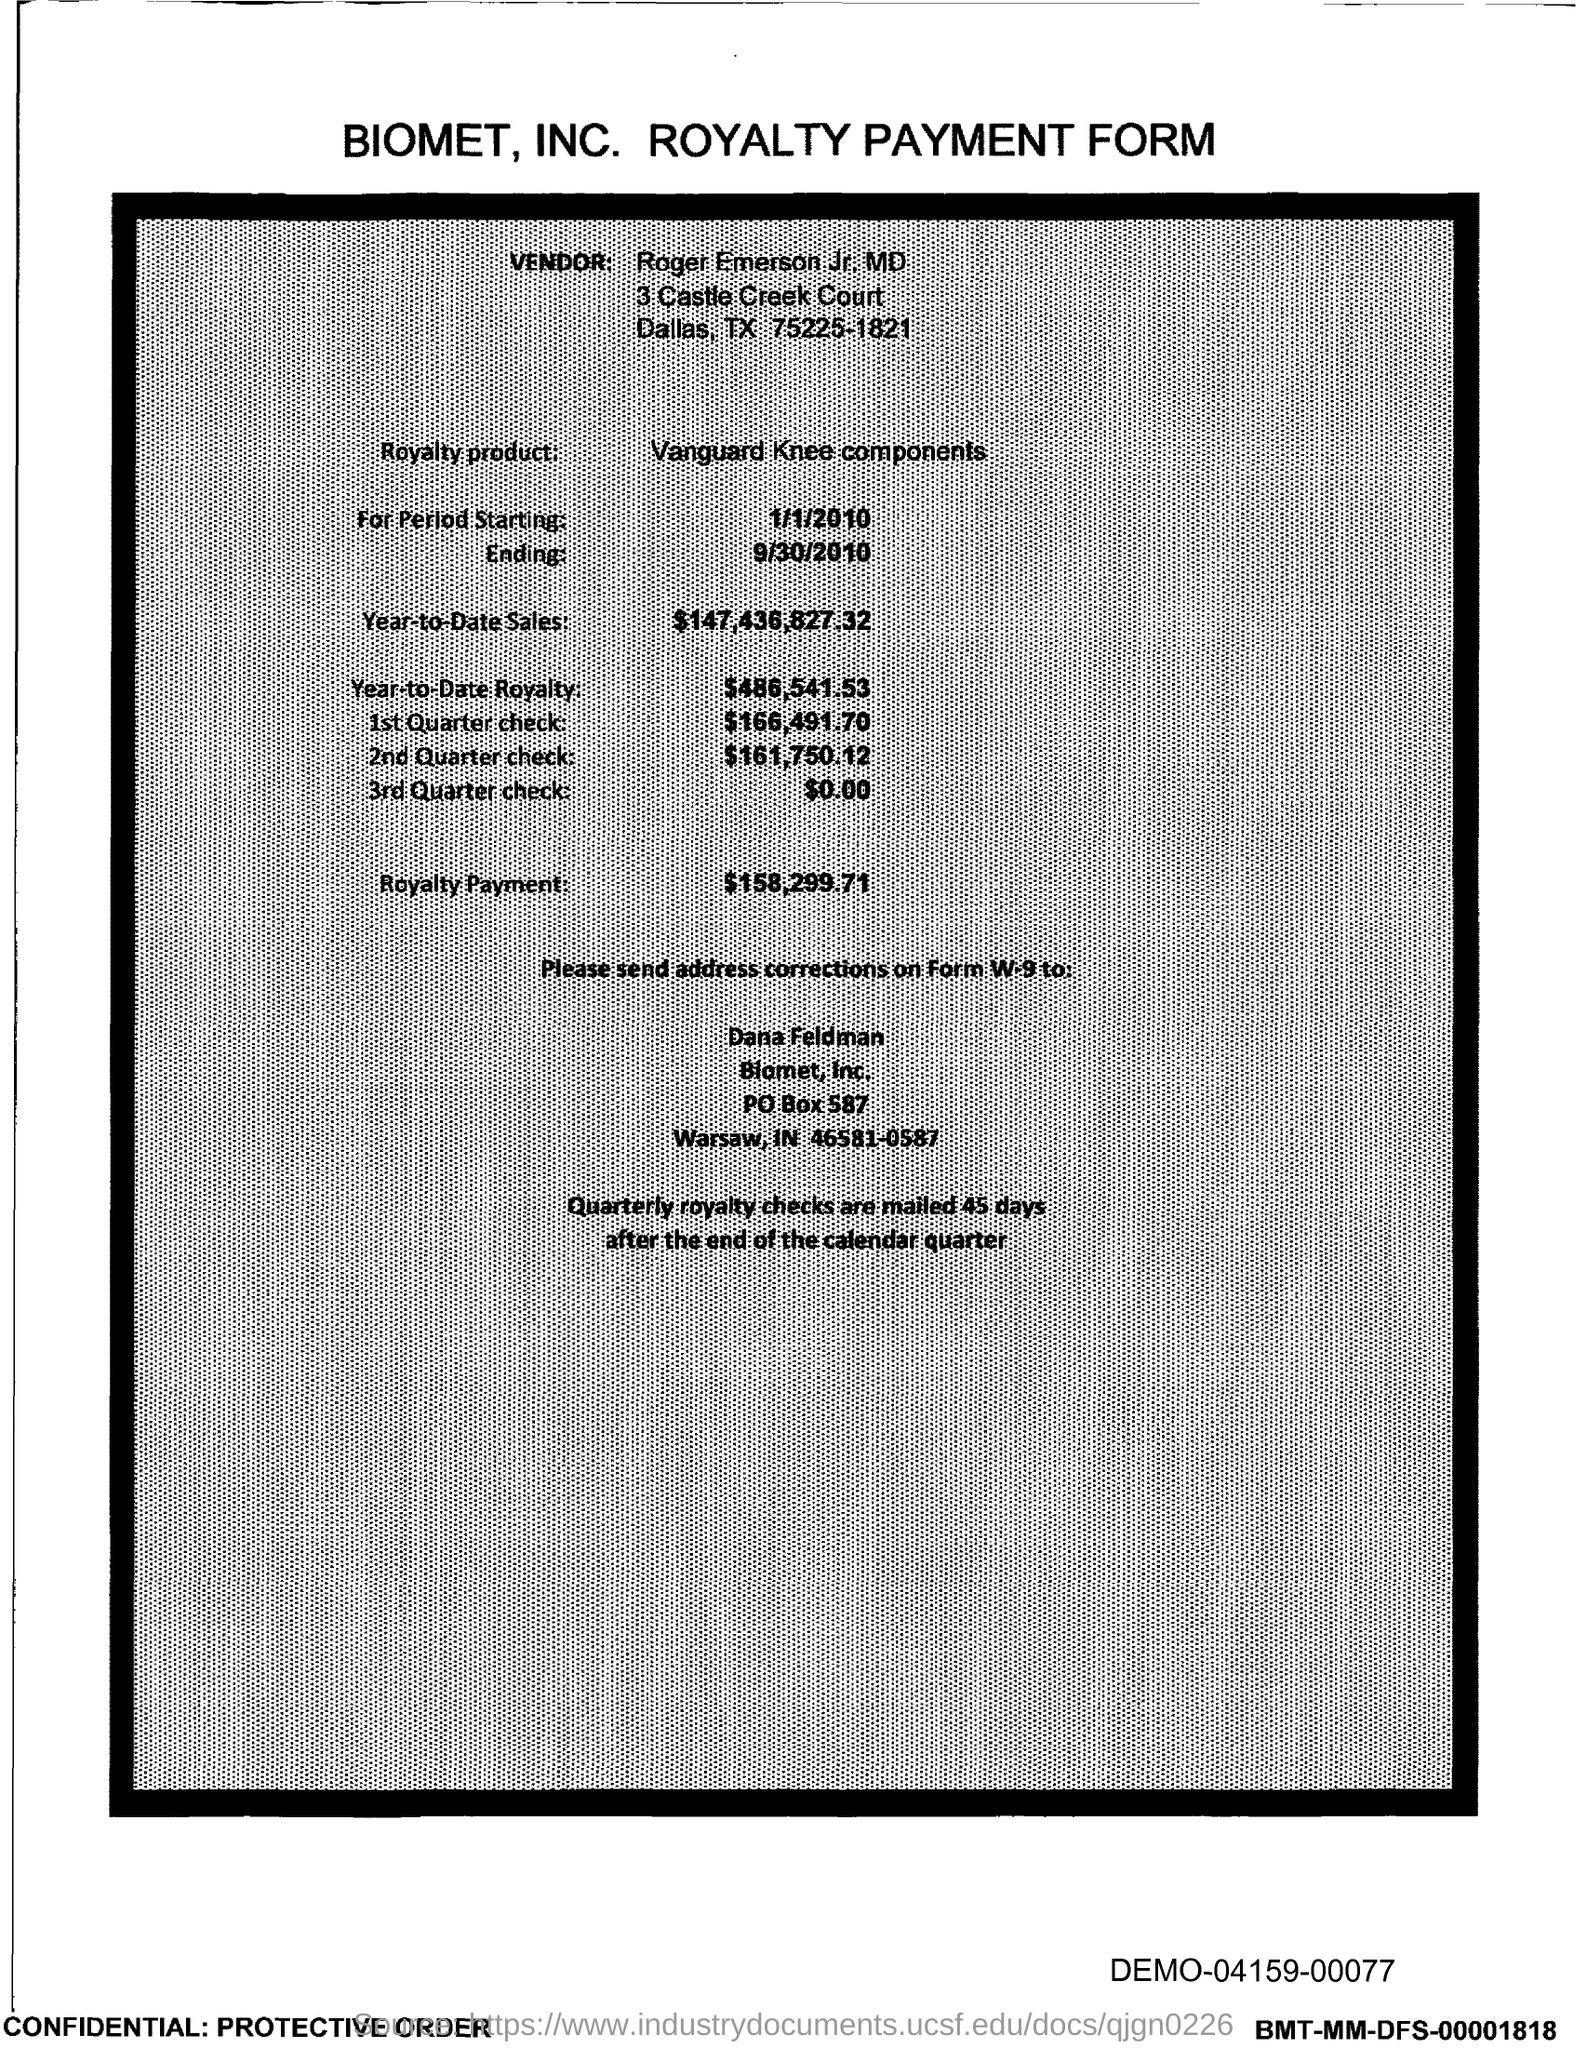What kind of form is this?
Ensure brevity in your answer.  ROYALTY PAYMENT FORM. Who is the vendor mentioned in the form?
Provide a succinct answer. Roger Emerson Jr. MD. What is the royalty product given in the form?
Ensure brevity in your answer.  Vanguard Knee components. What is the Year-to-Date Sales of the royalty product?
Give a very brief answer. $147,436,827,32. What is the Year-to-Date royalty given in the form?
Give a very brief answer. 486,541.53. How much is the royalty payment mentioned in the form?
Your answer should be compact. 158,299.71. Which company's royalty payment form is this?
Give a very brief answer. BIOMET, INC. What is the amount of 1st quarter check mentioned in the form?
Your answer should be very brief. 166,491.70. What is the amount of 2nd Quarter check mentioned in the form?
Offer a terse response. 161,750.12. What is the amount of 3rd Quarter check given in the form?
Give a very brief answer. 0.00. 